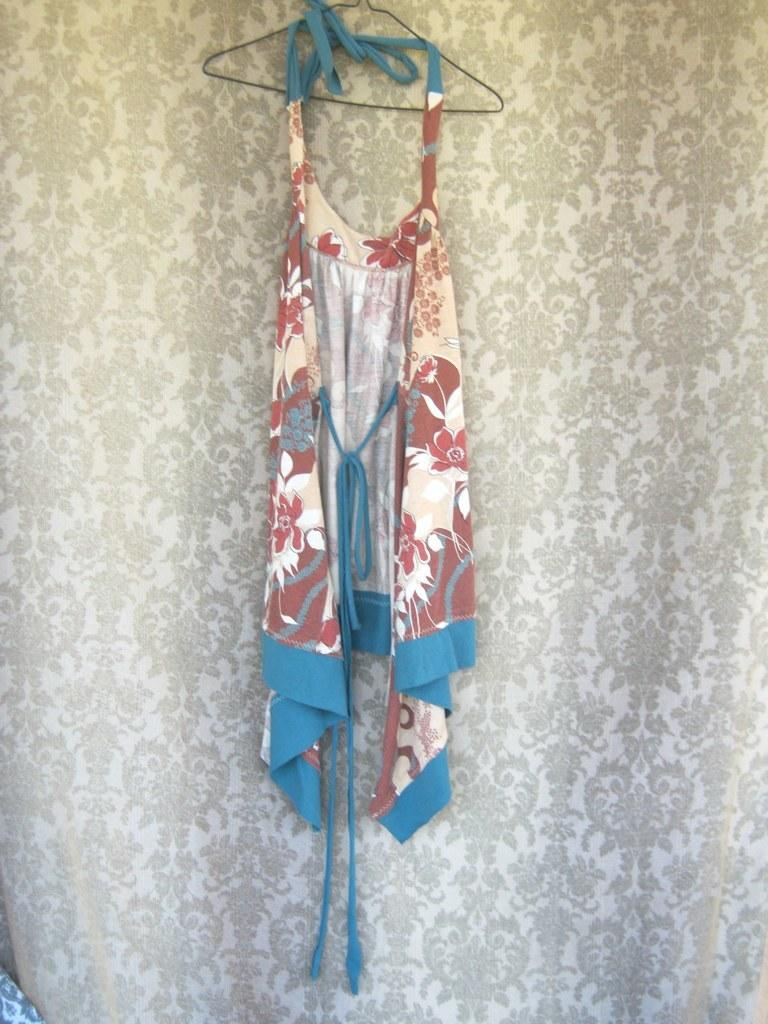What type of fabric accessory is present in the image? There is a curtain in the image. What type of clothing item is hanging in the image? There is a dress on a hanger in the image. What object can be seen on a surface in the image? The details of the object are not specified, but it is present on a surface in the image. What type of laborer is working in the image? There is no laborer present in the image. What country is depicted in the image? The image does not depict a country; it contains a curtain, a dress on a hanger, and an object on a surface. 